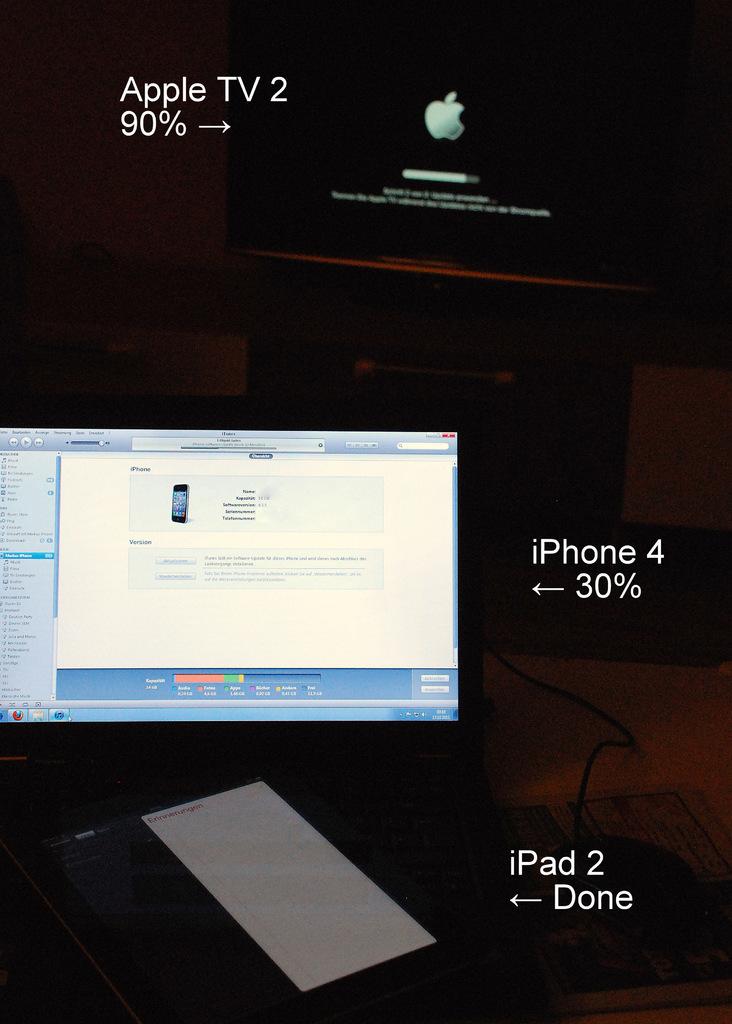What % is the apple tv 2?
Your response must be concise. 90. 